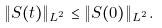<formula> <loc_0><loc_0><loc_500><loc_500>\| S ( t ) \| _ { L ^ { 2 } } \leq \| S ( 0 ) \| _ { L ^ { 2 } } .</formula> 